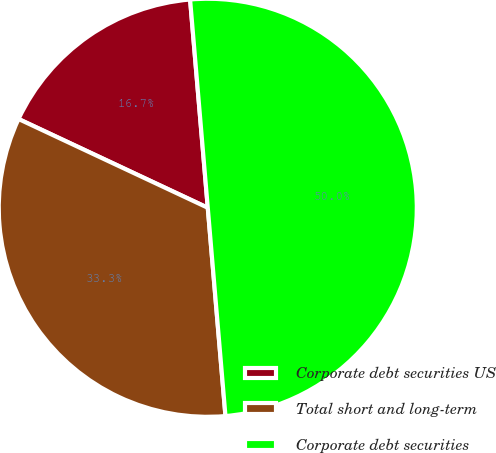Convert chart to OTSL. <chart><loc_0><loc_0><loc_500><loc_500><pie_chart><fcel>Corporate debt securities US<fcel>Total short and long-term<fcel>Corporate debt securities<nl><fcel>16.67%<fcel>33.33%<fcel>50.0%<nl></chart> 